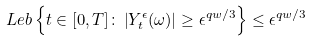<formula> <loc_0><loc_0><loc_500><loc_500>L e b \left \{ t \in [ 0 , T ] \colon \left | Y _ { t } ^ { \epsilon } ( \omega ) \right | \geq \epsilon ^ { q w / 3 } \right \} \leq \epsilon ^ { q w / 3 }</formula> 